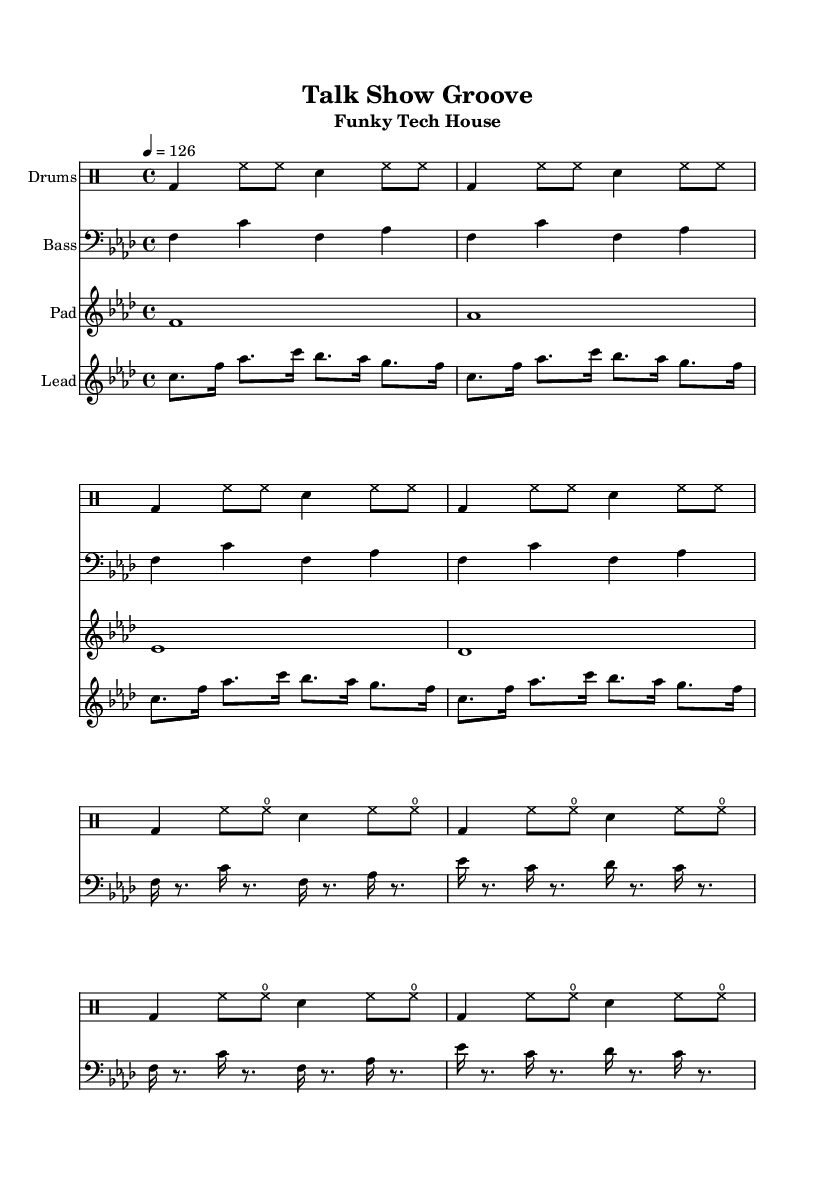What is the key signature of this music? The key signature is indicated by the flat symbols at the beginning of the staff. In this case, there are four flats, which corresponds to F minor.
Answer: F minor What is the time signature of the piece? The time signature is located at the beginning of the score and is shown as 4/4, indicating that there are four beats per measure, and the quarter note receives one beat.
Answer: 4/4 What is the tempo marking of the piece? The tempo marking indicates the speed at which the music should be played. It is given in beats per minute; in this case, it states 4 equals 126, meaning that a quarter note should be played at a speed of 126 beats per minute.
Answer: 126 How many measures are in the drum pattern intro? The drum pattern intro consists of four measures, as seen by the grouping of the notes and the end of the rhythmic phrases.
Answer: Four What is different about the bass section in the main part compared to the intro? In the main part, the bass has a more complex rhythm featuring sixteenth notes, while the intro consists of quarter notes and the same pitch pattern. This change enhances the groove typical in House music, creating more movement and energy.
Answer: Rhythmic complexity Which element contributes most to the 'funky' feel in the lead section? The lead section employs syncopated rhythms and accented notes that create an infectious groove characteristic of funky music. By alternating the note lengths and incorporating off-beat accents, it adds to the funk element.
Answer: Syncopation 